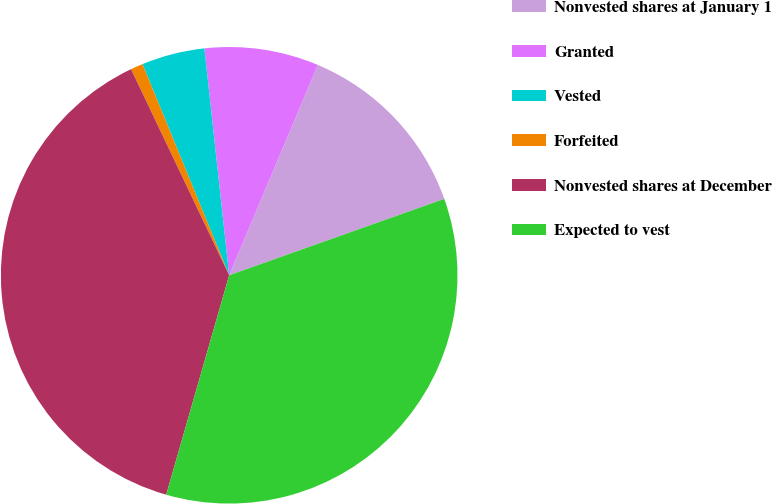Convert chart. <chart><loc_0><loc_0><loc_500><loc_500><pie_chart><fcel>Nonvested shares at January 1<fcel>Granted<fcel>Vested<fcel>Forfeited<fcel>Nonvested shares at December<fcel>Expected to vest<nl><fcel>13.22%<fcel>8.08%<fcel>4.47%<fcel>0.87%<fcel>38.48%<fcel>34.88%<nl></chart> 